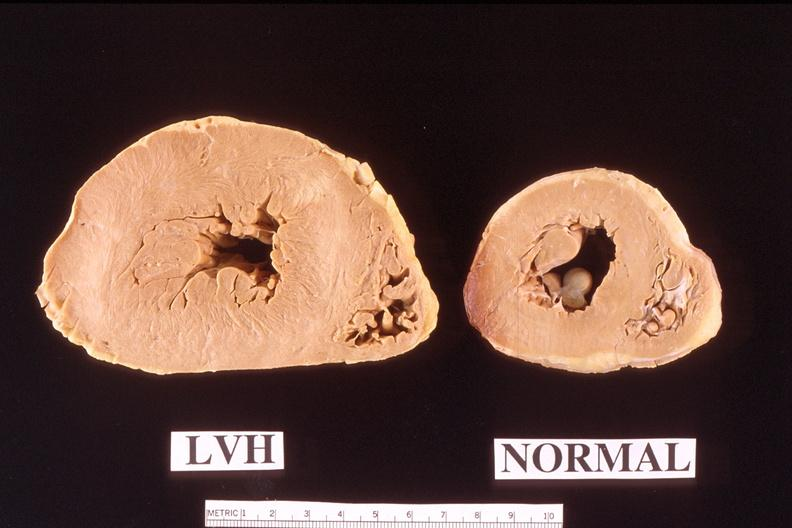what is heart left?
Answer the question using a single word or phrase. Ventricular hypertrophy compared to normal 